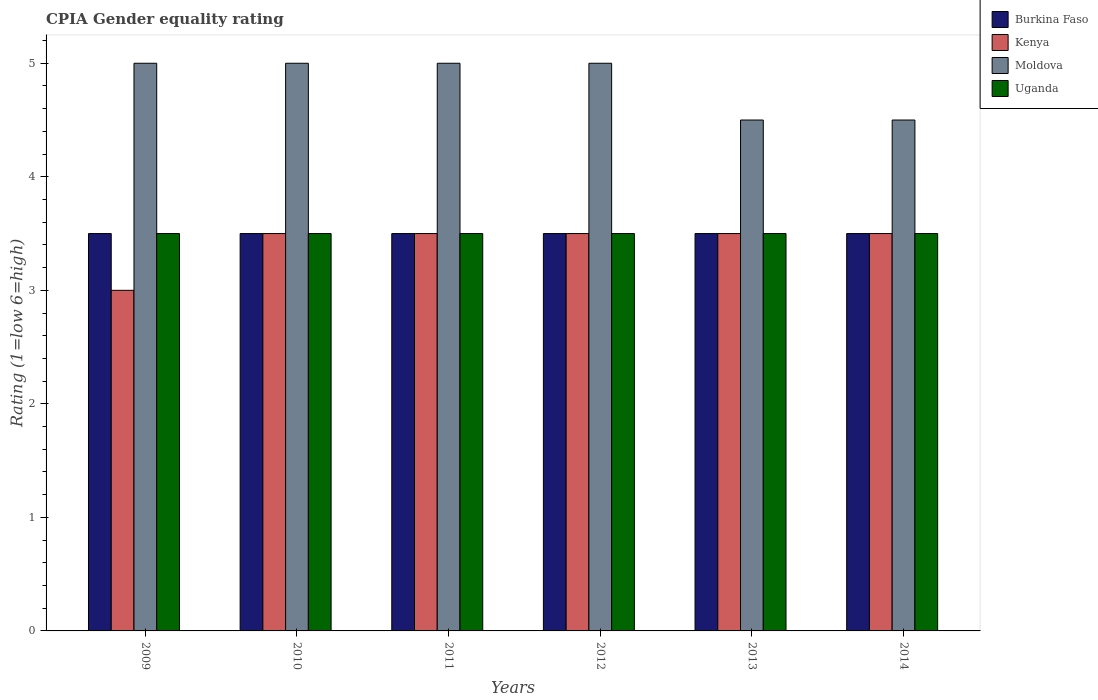How many groups of bars are there?
Provide a short and direct response. 6. Are the number of bars on each tick of the X-axis equal?
Offer a very short reply. Yes. How many bars are there on the 3rd tick from the left?
Offer a very short reply. 4. How many bars are there on the 2nd tick from the right?
Provide a succinct answer. 4. In how many cases, is the number of bars for a given year not equal to the number of legend labels?
Make the answer very short. 0. Across all years, what is the maximum CPIA rating in Moldova?
Ensure brevity in your answer.  5. Across all years, what is the minimum CPIA rating in Uganda?
Provide a succinct answer. 3.5. In which year was the CPIA rating in Burkina Faso minimum?
Offer a very short reply. 2009. What is the difference between the CPIA rating in Uganda in 2010 and that in 2013?
Give a very brief answer. 0. What is the difference between the CPIA rating in Uganda in 2010 and the CPIA rating in Kenya in 2014?
Your response must be concise. 0. What is the average CPIA rating in Moldova per year?
Your answer should be compact. 4.83. What is the ratio of the CPIA rating in Burkina Faso in 2009 to that in 2014?
Provide a succinct answer. 1. Is the CPIA rating in Uganda in 2010 less than that in 2013?
Provide a short and direct response. No. What is the difference between the highest and the second highest CPIA rating in Moldova?
Give a very brief answer. 0. In how many years, is the CPIA rating in Uganda greater than the average CPIA rating in Uganda taken over all years?
Give a very brief answer. 0. Is it the case that in every year, the sum of the CPIA rating in Burkina Faso and CPIA rating in Uganda is greater than the sum of CPIA rating in Moldova and CPIA rating in Kenya?
Offer a very short reply. No. What does the 2nd bar from the left in 2009 represents?
Keep it short and to the point. Kenya. What does the 3rd bar from the right in 2014 represents?
Provide a short and direct response. Kenya. Is it the case that in every year, the sum of the CPIA rating in Uganda and CPIA rating in Burkina Faso is greater than the CPIA rating in Moldova?
Ensure brevity in your answer.  Yes. Are all the bars in the graph horizontal?
Provide a succinct answer. No. How many years are there in the graph?
Make the answer very short. 6. Are the values on the major ticks of Y-axis written in scientific E-notation?
Keep it short and to the point. No. Does the graph contain any zero values?
Keep it short and to the point. No. Where does the legend appear in the graph?
Your answer should be very brief. Top right. How many legend labels are there?
Keep it short and to the point. 4. What is the title of the graph?
Keep it short and to the point. CPIA Gender equality rating. What is the label or title of the X-axis?
Offer a terse response. Years. What is the Rating (1=low 6=high) of Burkina Faso in 2009?
Offer a very short reply. 3.5. What is the Rating (1=low 6=high) in Kenya in 2009?
Keep it short and to the point. 3. What is the Rating (1=low 6=high) of Uganda in 2009?
Ensure brevity in your answer.  3.5. What is the Rating (1=low 6=high) of Moldova in 2010?
Offer a very short reply. 5. What is the Rating (1=low 6=high) of Kenya in 2011?
Make the answer very short. 3.5. What is the Rating (1=low 6=high) of Uganda in 2011?
Make the answer very short. 3.5. What is the Rating (1=low 6=high) of Burkina Faso in 2012?
Your answer should be very brief. 3.5. What is the Rating (1=low 6=high) in Moldova in 2012?
Offer a terse response. 5. What is the Rating (1=low 6=high) of Kenya in 2013?
Give a very brief answer. 3.5. What is the Rating (1=low 6=high) in Moldova in 2013?
Your answer should be compact. 4.5. What is the Rating (1=low 6=high) in Uganda in 2013?
Your answer should be very brief. 3.5. What is the Rating (1=low 6=high) of Kenya in 2014?
Offer a terse response. 3.5. Across all years, what is the maximum Rating (1=low 6=high) of Burkina Faso?
Your answer should be very brief. 3.5. Across all years, what is the maximum Rating (1=low 6=high) of Kenya?
Keep it short and to the point. 3.5. Across all years, what is the maximum Rating (1=low 6=high) in Moldova?
Provide a short and direct response. 5. Across all years, what is the maximum Rating (1=low 6=high) in Uganda?
Your answer should be compact. 3.5. Across all years, what is the minimum Rating (1=low 6=high) of Burkina Faso?
Make the answer very short. 3.5. Across all years, what is the minimum Rating (1=low 6=high) in Moldova?
Make the answer very short. 4.5. Across all years, what is the minimum Rating (1=low 6=high) in Uganda?
Make the answer very short. 3.5. What is the total Rating (1=low 6=high) of Moldova in the graph?
Make the answer very short. 29. What is the total Rating (1=low 6=high) of Uganda in the graph?
Your response must be concise. 21. What is the difference between the Rating (1=low 6=high) in Burkina Faso in 2009 and that in 2010?
Provide a succinct answer. 0. What is the difference between the Rating (1=low 6=high) of Moldova in 2009 and that in 2010?
Your answer should be very brief. 0. What is the difference between the Rating (1=low 6=high) in Uganda in 2009 and that in 2010?
Your answer should be very brief. 0. What is the difference between the Rating (1=low 6=high) in Burkina Faso in 2009 and that in 2011?
Keep it short and to the point. 0. What is the difference between the Rating (1=low 6=high) of Kenya in 2009 and that in 2011?
Offer a very short reply. -0.5. What is the difference between the Rating (1=low 6=high) in Moldova in 2009 and that in 2011?
Provide a short and direct response. 0. What is the difference between the Rating (1=low 6=high) of Kenya in 2009 and that in 2013?
Your response must be concise. -0.5. What is the difference between the Rating (1=low 6=high) of Moldova in 2009 and that in 2013?
Offer a very short reply. 0.5. What is the difference between the Rating (1=low 6=high) in Burkina Faso in 2009 and that in 2014?
Keep it short and to the point. 0. What is the difference between the Rating (1=low 6=high) in Kenya in 2009 and that in 2014?
Give a very brief answer. -0.5. What is the difference between the Rating (1=low 6=high) in Moldova in 2009 and that in 2014?
Provide a succinct answer. 0.5. What is the difference between the Rating (1=low 6=high) in Uganda in 2009 and that in 2014?
Ensure brevity in your answer.  0. What is the difference between the Rating (1=low 6=high) of Kenya in 2010 and that in 2012?
Offer a terse response. 0. What is the difference between the Rating (1=low 6=high) of Burkina Faso in 2010 and that in 2013?
Your answer should be very brief. 0. What is the difference between the Rating (1=low 6=high) in Kenya in 2010 and that in 2013?
Provide a succinct answer. 0. What is the difference between the Rating (1=low 6=high) of Uganda in 2010 and that in 2013?
Your answer should be very brief. 0. What is the difference between the Rating (1=low 6=high) in Burkina Faso in 2010 and that in 2014?
Offer a very short reply. 0. What is the difference between the Rating (1=low 6=high) in Kenya in 2011 and that in 2012?
Provide a succinct answer. 0. What is the difference between the Rating (1=low 6=high) of Uganda in 2011 and that in 2012?
Keep it short and to the point. 0. What is the difference between the Rating (1=low 6=high) in Burkina Faso in 2011 and that in 2013?
Offer a terse response. 0. What is the difference between the Rating (1=low 6=high) in Uganda in 2011 and that in 2013?
Offer a terse response. 0. What is the difference between the Rating (1=low 6=high) of Burkina Faso in 2011 and that in 2014?
Provide a succinct answer. 0. What is the difference between the Rating (1=low 6=high) in Moldova in 2011 and that in 2014?
Provide a short and direct response. 0.5. What is the difference between the Rating (1=low 6=high) in Burkina Faso in 2012 and that in 2013?
Offer a very short reply. 0. What is the difference between the Rating (1=low 6=high) in Kenya in 2012 and that in 2013?
Make the answer very short. 0. What is the difference between the Rating (1=low 6=high) of Burkina Faso in 2009 and the Rating (1=low 6=high) of Kenya in 2010?
Your answer should be very brief. 0. What is the difference between the Rating (1=low 6=high) of Kenya in 2009 and the Rating (1=low 6=high) of Moldova in 2010?
Provide a succinct answer. -2. What is the difference between the Rating (1=low 6=high) of Moldova in 2009 and the Rating (1=low 6=high) of Uganda in 2010?
Offer a very short reply. 1.5. What is the difference between the Rating (1=low 6=high) in Burkina Faso in 2009 and the Rating (1=low 6=high) in Kenya in 2011?
Offer a very short reply. 0. What is the difference between the Rating (1=low 6=high) in Burkina Faso in 2009 and the Rating (1=low 6=high) in Moldova in 2011?
Your answer should be very brief. -1.5. What is the difference between the Rating (1=low 6=high) of Burkina Faso in 2009 and the Rating (1=low 6=high) of Uganda in 2011?
Offer a very short reply. 0. What is the difference between the Rating (1=low 6=high) in Burkina Faso in 2009 and the Rating (1=low 6=high) in Kenya in 2012?
Keep it short and to the point. 0. What is the difference between the Rating (1=low 6=high) of Kenya in 2009 and the Rating (1=low 6=high) of Uganda in 2012?
Keep it short and to the point. -0.5. What is the difference between the Rating (1=low 6=high) in Burkina Faso in 2009 and the Rating (1=low 6=high) in Kenya in 2013?
Offer a terse response. 0. What is the difference between the Rating (1=low 6=high) in Burkina Faso in 2009 and the Rating (1=low 6=high) in Moldova in 2013?
Provide a succinct answer. -1. What is the difference between the Rating (1=low 6=high) in Burkina Faso in 2009 and the Rating (1=low 6=high) in Uganda in 2013?
Offer a terse response. 0. What is the difference between the Rating (1=low 6=high) in Burkina Faso in 2009 and the Rating (1=low 6=high) in Kenya in 2014?
Your response must be concise. 0. What is the difference between the Rating (1=low 6=high) of Kenya in 2009 and the Rating (1=low 6=high) of Moldova in 2014?
Make the answer very short. -1.5. What is the difference between the Rating (1=low 6=high) of Burkina Faso in 2010 and the Rating (1=low 6=high) of Kenya in 2011?
Give a very brief answer. 0. What is the difference between the Rating (1=low 6=high) of Burkina Faso in 2010 and the Rating (1=low 6=high) of Moldova in 2011?
Provide a succinct answer. -1.5. What is the difference between the Rating (1=low 6=high) of Burkina Faso in 2010 and the Rating (1=low 6=high) of Uganda in 2011?
Offer a terse response. 0. What is the difference between the Rating (1=low 6=high) in Moldova in 2010 and the Rating (1=low 6=high) in Uganda in 2011?
Provide a succinct answer. 1.5. What is the difference between the Rating (1=low 6=high) of Burkina Faso in 2010 and the Rating (1=low 6=high) of Kenya in 2012?
Give a very brief answer. 0. What is the difference between the Rating (1=low 6=high) in Burkina Faso in 2010 and the Rating (1=low 6=high) in Moldova in 2012?
Provide a succinct answer. -1.5. What is the difference between the Rating (1=low 6=high) of Burkina Faso in 2010 and the Rating (1=low 6=high) of Kenya in 2013?
Your answer should be very brief. 0. What is the difference between the Rating (1=low 6=high) of Moldova in 2010 and the Rating (1=low 6=high) of Uganda in 2013?
Ensure brevity in your answer.  1.5. What is the difference between the Rating (1=low 6=high) of Kenya in 2010 and the Rating (1=low 6=high) of Uganda in 2014?
Provide a succinct answer. 0. What is the difference between the Rating (1=low 6=high) of Burkina Faso in 2011 and the Rating (1=low 6=high) of Moldova in 2012?
Keep it short and to the point. -1.5. What is the difference between the Rating (1=low 6=high) of Kenya in 2011 and the Rating (1=low 6=high) of Moldova in 2013?
Keep it short and to the point. -1. What is the difference between the Rating (1=low 6=high) of Kenya in 2011 and the Rating (1=low 6=high) of Moldova in 2014?
Make the answer very short. -1. What is the difference between the Rating (1=low 6=high) in Burkina Faso in 2012 and the Rating (1=low 6=high) in Kenya in 2013?
Make the answer very short. 0. What is the difference between the Rating (1=low 6=high) of Kenya in 2012 and the Rating (1=low 6=high) of Uganda in 2013?
Provide a succinct answer. 0. What is the difference between the Rating (1=low 6=high) in Moldova in 2012 and the Rating (1=low 6=high) in Uganda in 2013?
Your answer should be very brief. 1.5. What is the difference between the Rating (1=low 6=high) in Burkina Faso in 2012 and the Rating (1=low 6=high) in Kenya in 2014?
Ensure brevity in your answer.  0. What is the difference between the Rating (1=low 6=high) in Burkina Faso in 2012 and the Rating (1=low 6=high) in Moldova in 2014?
Your response must be concise. -1. What is the difference between the Rating (1=low 6=high) of Kenya in 2012 and the Rating (1=low 6=high) of Moldova in 2014?
Your answer should be very brief. -1. What is the difference between the Rating (1=low 6=high) in Burkina Faso in 2013 and the Rating (1=low 6=high) in Moldova in 2014?
Keep it short and to the point. -1. What is the difference between the Rating (1=low 6=high) of Burkina Faso in 2013 and the Rating (1=low 6=high) of Uganda in 2014?
Your answer should be compact. 0. What is the difference between the Rating (1=low 6=high) in Kenya in 2013 and the Rating (1=low 6=high) in Moldova in 2014?
Keep it short and to the point. -1. What is the difference between the Rating (1=low 6=high) of Kenya in 2013 and the Rating (1=low 6=high) of Uganda in 2014?
Give a very brief answer. 0. What is the average Rating (1=low 6=high) in Burkina Faso per year?
Make the answer very short. 3.5. What is the average Rating (1=low 6=high) of Kenya per year?
Offer a very short reply. 3.42. What is the average Rating (1=low 6=high) of Moldova per year?
Your response must be concise. 4.83. What is the average Rating (1=low 6=high) in Uganda per year?
Your response must be concise. 3.5. In the year 2009, what is the difference between the Rating (1=low 6=high) of Burkina Faso and Rating (1=low 6=high) of Kenya?
Offer a very short reply. 0.5. In the year 2009, what is the difference between the Rating (1=low 6=high) in Moldova and Rating (1=low 6=high) in Uganda?
Make the answer very short. 1.5. In the year 2010, what is the difference between the Rating (1=low 6=high) in Burkina Faso and Rating (1=low 6=high) in Kenya?
Keep it short and to the point. 0. In the year 2010, what is the difference between the Rating (1=low 6=high) in Burkina Faso and Rating (1=low 6=high) in Moldova?
Keep it short and to the point. -1.5. In the year 2010, what is the difference between the Rating (1=low 6=high) in Burkina Faso and Rating (1=low 6=high) in Uganda?
Make the answer very short. 0. In the year 2011, what is the difference between the Rating (1=low 6=high) of Burkina Faso and Rating (1=low 6=high) of Moldova?
Your response must be concise. -1.5. In the year 2011, what is the difference between the Rating (1=low 6=high) of Burkina Faso and Rating (1=low 6=high) of Uganda?
Make the answer very short. 0. In the year 2011, what is the difference between the Rating (1=low 6=high) of Kenya and Rating (1=low 6=high) of Uganda?
Ensure brevity in your answer.  0. In the year 2012, what is the difference between the Rating (1=low 6=high) in Burkina Faso and Rating (1=low 6=high) in Kenya?
Your answer should be very brief. 0. In the year 2012, what is the difference between the Rating (1=low 6=high) in Burkina Faso and Rating (1=low 6=high) in Uganda?
Offer a terse response. 0. In the year 2012, what is the difference between the Rating (1=low 6=high) in Kenya and Rating (1=low 6=high) in Moldova?
Ensure brevity in your answer.  -1.5. In the year 2013, what is the difference between the Rating (1=low 6=high) in Kenya and Rating (1=low 6=high) in Uganda?
Ensure brevity in your answer.  0. In the year 2013, what is the difference between the Rating (1=low 6=high) in Moldova and Rating (1=low 6=high) in Uganda?
Offer a very short reply. 1. In the year 2014, what is the difference between the Rating (1=low 6=high) of Burkina Faso and Rating (1=low 6=high) of Kenya?
Offer a very short reply. 0. In the year 2014, what is the difference between the Rating (1=low 6=high) of Burkina Faso and Rating (1=low 6=high) of Uganda?
Give a very brief answer. 0. In the year 2014, what is the difference between the Rating (1=low 6=high) in Kenya and Rating (1=low 6=high) in Moldova?
Offer a terse response. -1. In the year 2014, what is the difference between the Rating (1=low 6=high) of Kenya and Rating (1=low 6=high) of Uganda?
Keep it short and to the point. 0. What is the ratio of the Rating (1=low 6=high) of Burkina Faso in 2009 to that in 2010?
Keep it short and to the point. 1. What is the ratio of the Rating (1=low 6=high) of Moldova in 2009 to that in 2010?
Provide a succinct answer. 1. What is the ratio of the Rating (1=low 6=high) in Burkina Faso in 2009 to that in 2011?
Your answer should be very brief. 1. What is the ratio of the Rating (1=low 6=high) in Kenya in 2009 to that in 2011?
Ensure brevity in your answer.  0.86. What is the ratio of the Rating (1=low 6=high) in Moldova in 2009 to that in 2011?
Your response must be concise. 1. What is the ratio of the Rating (1=low 6=high) of Uganda in 2009 to that in 2011?
Your response must be concise. 1. What is the ratio of the Rating (1=low 6=high) of Burkina Faso in 2009 to that in 2012?
Your answer should be very brief. 1. What is the ratio of the Rating (1=low 6=high) in Kenya in 2009 to that in 2012?
Provide a succinct answer. 0.86. What is the ratio of the Rating (1=low 6=high) of Moldova in 2009 to that in 2012?
Your answer should be very brief. 1. What is the ratio of the Rating (1=low 6=high) in Uganda in 2009 to that in 2012?
Give a very brief answer. 1. What is the ratio of the Rating (1=low 6=high) of Burkina Faso in 2009 to that in 2013?
Provide a succinct answer. 1. What is the ratio of the Rating (1=low 6=high) of Moldova in 2009 to that in 2013?
Make the answer very short. 1.11. What is the ratio of the Rating (1=low 6=high) of Moldova in 2009 to that in 2014?
Give a very brief answer. 1.11. What is the ratio of the Rating (1=low 6=high) in Uganda in 2009 to that in 2014?
Make the answer very short. 1. What is the ratio of the Rating (1=low 6=high) in Kenya in 2010 to that in 2011?
Give a very brief answer. 1. What is the ratio of the Rating (1=low 6=high) in Moldova in 2010 to that in 2011?
Ensure brevity in your answer.  1. What is the ratio of the Rating (1=low 6=high) of Uganda in 2010 to that in 2011?
Provide a succinct answer. 1. What is the ratio of the Rating (1=low 6=high) of Kenya in 2010 to that in 2012?
Make the answer very short. 1. What is the ratio of the Rating (1=low 6=high) of Burkina Faso in 2010 to that in 2013?
Provide a succinct answer. 1. What is the ratio of the Rating (1=low 6=high) of Moldova in 2010 to that in 2013?
Your answer should be compact. 1.11. What is the ratio of the Rating (1=low 6=high) in Uganda in 2010 to that in 2013?
Offer a very short reply. 1. What is the ratio of the Rating (1=low 6=high) of Kenya in 2010 to that in 2014?
Your response must be concise. 1. What is the ratio of the Rating (1=low 6=high) in Moldova in 2010 to that in 2014?
Your answer should be very brief. 1.11. What is the ratio of the Rating (1=low 6=high) of Burkina Faso in 2011 to that in 2012?
Give a very brief answer. 1. What is the ratio of the Rating (1=low 6=high) in Moldova in 2011 to that in 2012?
Your response must be concise. 1. What is the ratio of the Rating (1=low 6=high) of Uganda in 2011 to that in 2012?
Provide a succinct answer. 1. What is the ratio of the Rating (1=low 6=high) of Burkina Faso in 2011 to that in 2013?
Give a very brief answer. 1. What is the ratio of the Rating (1=low 6=high) in Moldova in 2011 to that in 2013?
Your response must be concise. 1.11. What is the ratio of the Rating (1=low 6=high) in Uganda in 2011 to that in 2014?
Your answer should be compact. 1. What is the ratio of the Rating (1=low 6=high) in Burkina Faso in 2012 to that in 2013?
Offer a terse response. 1. What is the ratio of the Rating (1=low 6=high) of Uganda in 2012 to that in 2013?
Your answer should be very brief. 1. What is the ratio of the Rating (1=low 6=high) of Uganda in 2012 to that in 2014?
Offer a very short reply. 1. What is the ratio of the Rating (1=low 6=high) of Burkina Faso in 2013 to that in 2014?
Offer a very short reply. 1. What is the ratio of the Rating (1=low 6=high) in Moldova in 2013 to that in 2014?
Provide a succinct answer. 1. What is the difference between the highest and the second highest Rating (1=low 6=high) in Kenya?
Give a very brief answer. 0. What is the difference between the highest and the second highest Rating (1=low 6=high) of Moldova?
Provide a short and direct response. 0. What is the difference between the highest and the second highest Rating (1=low 6=high) of Uganda?
Make the answer very short. 0. What is the difference between the highest and the lowest Rating (1=low 6=high) in Moldova?
Keep it short and to the point. 0.5. 